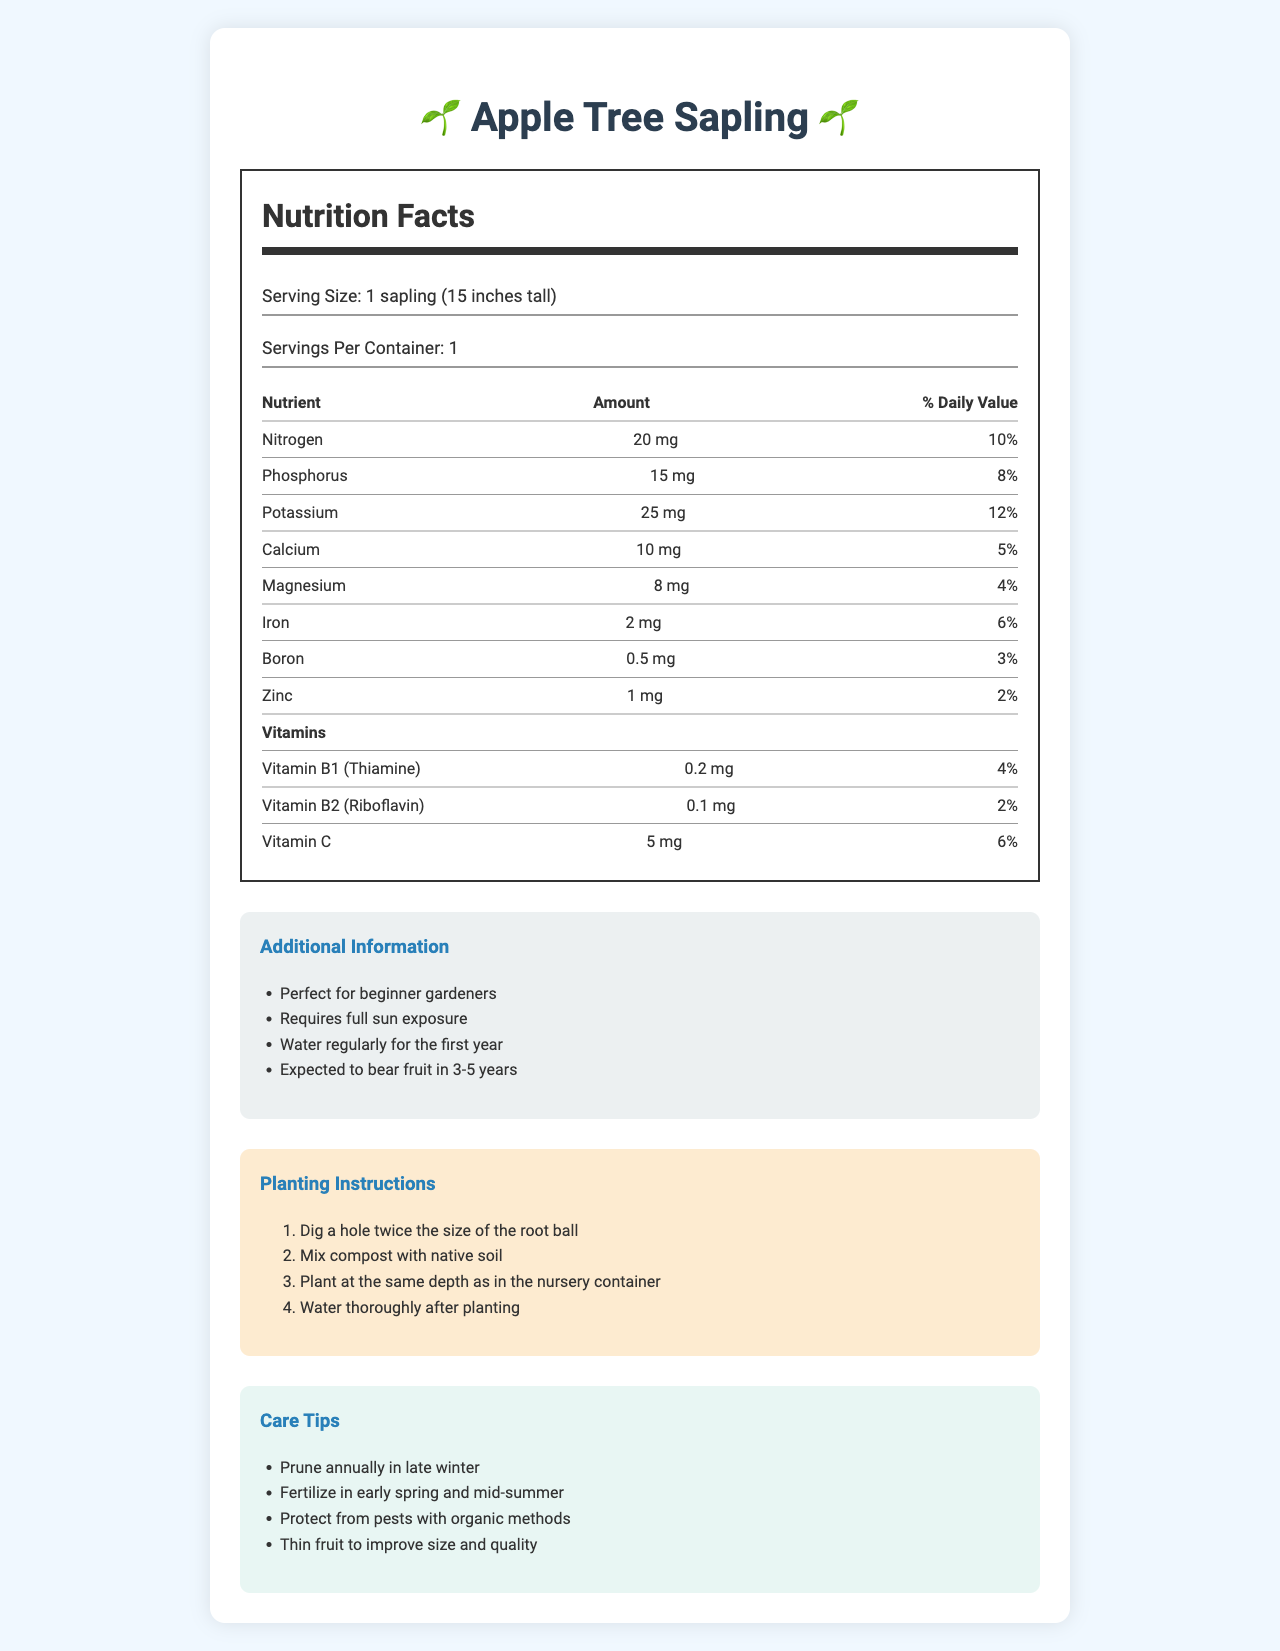what is the serving size for the Apple Tree Sapling? The document specifies the serving size as "1 sapling (15 inches tall)".
Answer: 1 sapling (15 inches tall) how much Nitrogen is in the sapling? According to the Nutrition Facts, there is 20 mg of Nitrogen.
Answer: 20 mg what is the price of the Apple Tree Sapling? The document does not provide any information about the price.
Answer: Not enough information what percentage of daily value does Phosphorus provide? The Nutrition Facts label shows that Phosphorus provides 8% of the daily value.
Answer: 8% how often should the Apple Tree Sapling be watered in the first year? The additional information section states that it should be "Watered regularly for the first year".
Answer: regularly what are the instructions for planting the sapling? The planting instructions section specifies these steps.
Answer: Dig a hole twice the size of the root ball, mix compost with native soil, plant at the same depth as in the nursery container, water thoroughly after planting when is the Apple Tree Sapling expected to bear fruit? The additional information section mentions that the sapling is expected to bear fruit in 3-5 years.
Answer: 3-5 years which vitamin has the highest daily value percentage in the Apple Tree Sapling? A. Vitamin B1 B. Vitamin B2 C. Vitamin C The Nutrition Facts specify that Vitamin C has a daily value of 6%, which is the highest among the listed vitamins.
Answer: C how much Iron is present in the sapling? The Nutrition Facts state that there is 2 mg of Iron.
Answer: 2 mg what should be done to improve the size and quality of the fruit? The care tips section advises thinning the fruit to improve its size and quality.
Answer: Thin fruit how tall is the Apple Tree Sapling that is being provided? A. 10 inches B. 15 inches C. 20 inches D. 25 inches The serving size indicates that the sapling is 15 inches tall.
Answer: B is pruning required for the Apple Tree Sapling? The care tips section indicates that pruning annually in late winter is required.
Answer: Yes summarize the main content of the document. The main content covers all aspects from the nutrient information to practical gardening tips for successful apple tree cultivation.
Answer: The document provides a detailed overview of the Apple Tree Sapling, including its Nutrition Facts, necessary vitamins and minerals for healthy fruit production, additional information for beginner gardeners, planting instructions, and care tips to ensure healthy growth and fruit quality. It specifies the nutrients present, their amounts, and their daily values, as well as the specific steps to plant and care for the sapling. how much Zinc is in the Apple Tree Sapling? The Nutrition Facts show there is 1 mg of Zinc in the sapling.
Answer: 1 mg 